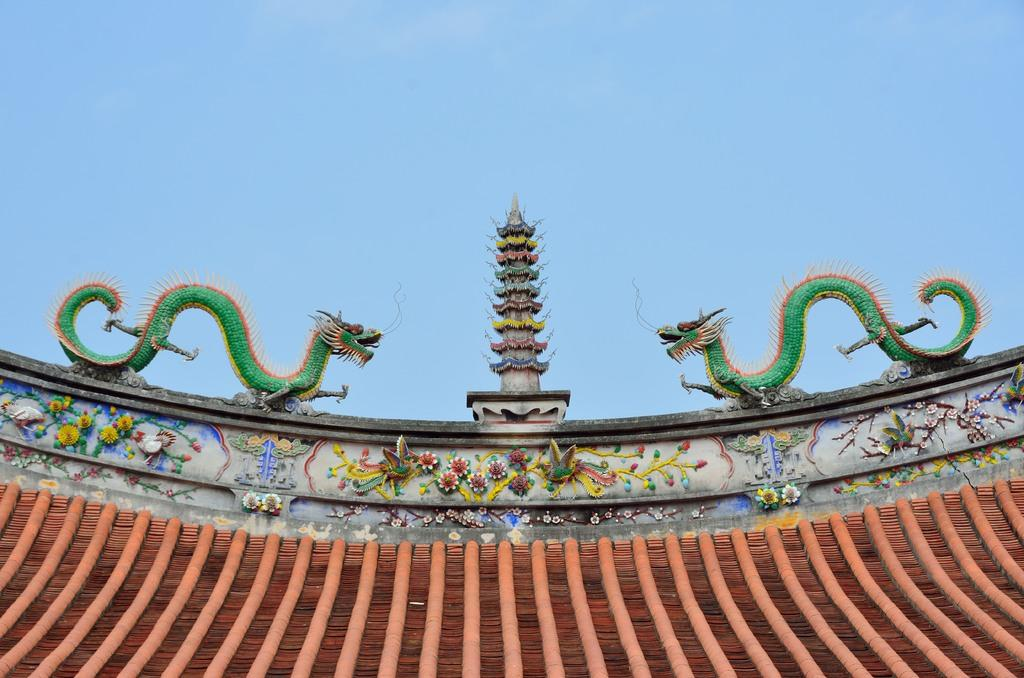What is the perspective of the image? The image shows a top view of a building. What decorative elements are present on the building? There are two dragons on the building. What structure is located between the two dragons? There is a tower between the two dragons. What material is the building made of? The building is made of bricks. Can you tell me how many guides are present in the image? There are no guides present in the image; it features a building with two dragons and a tower. What type of horn can be seen on the building in the image? There is no horn present on the building in the image; it features two dragons and a tower. 